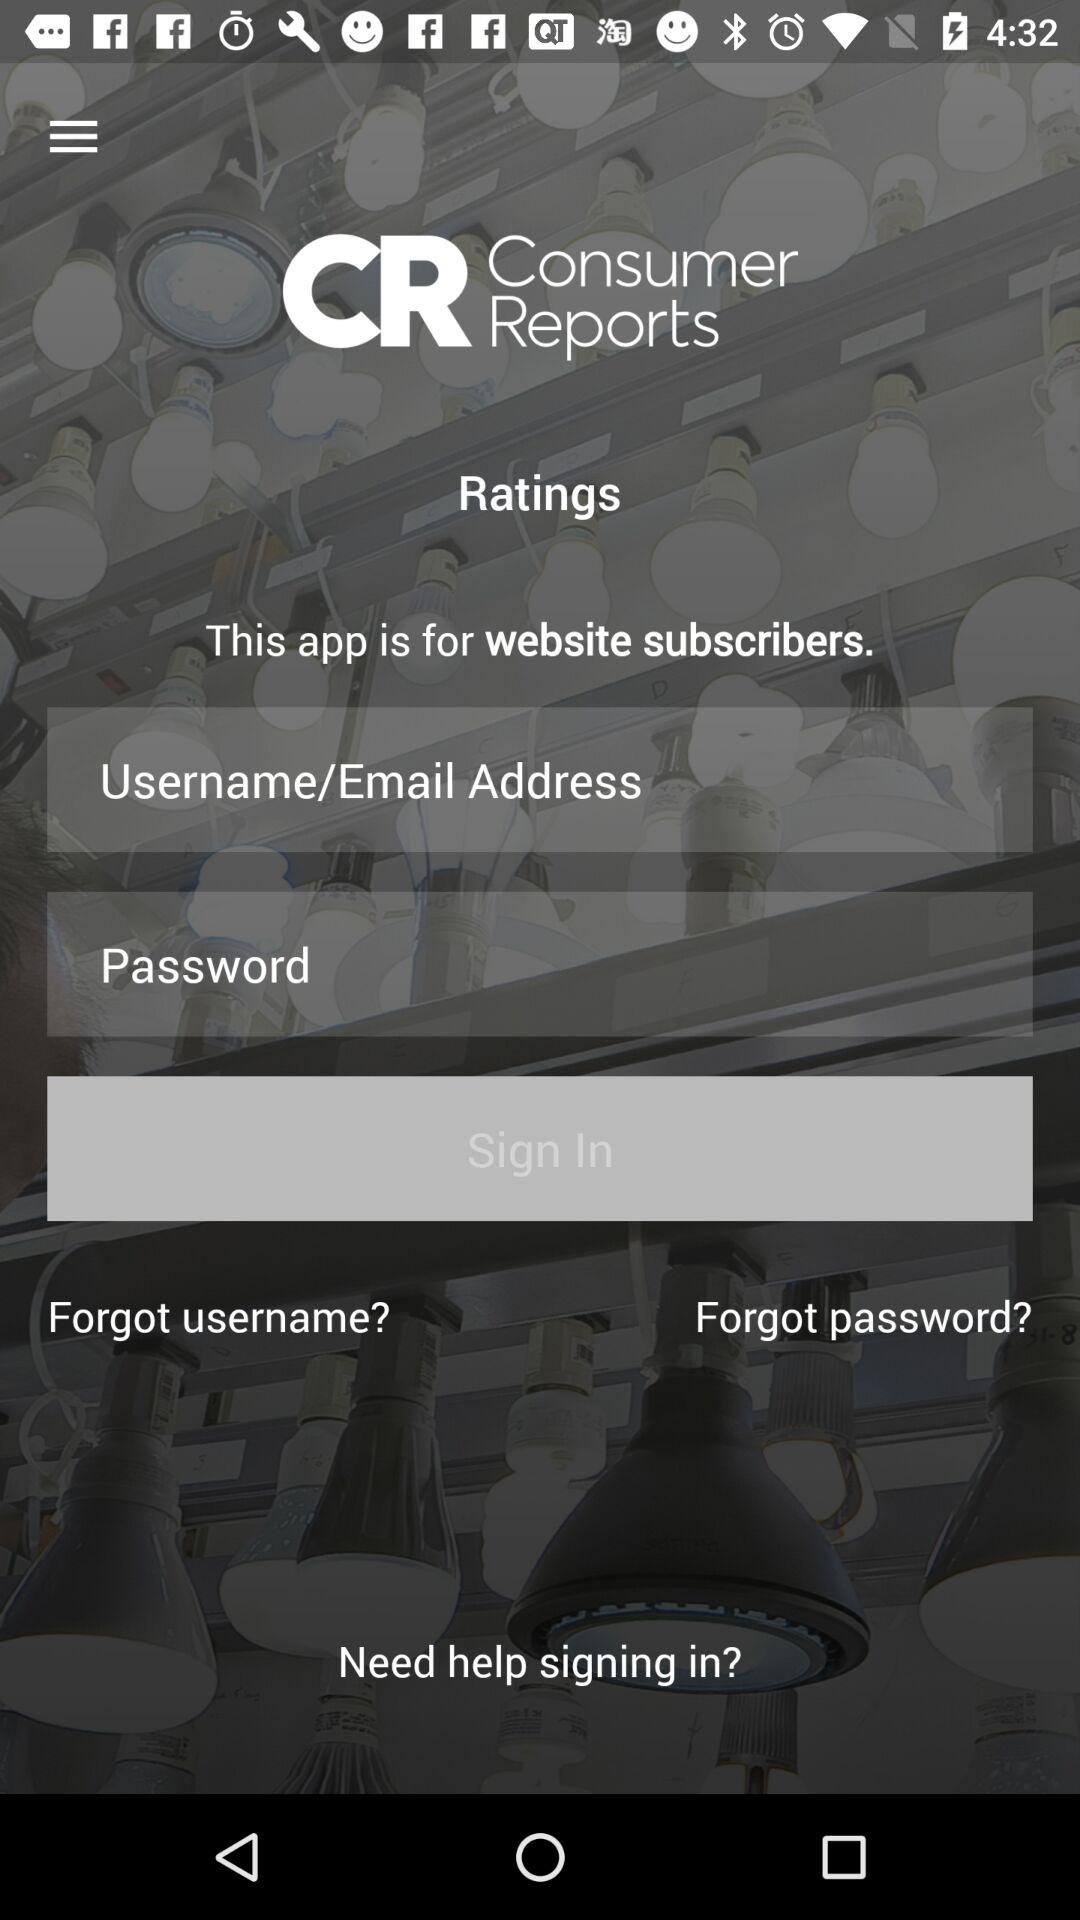Is the sign in form intended for new or existing users? The sign-in form is designed for existing users as it requests a username/email address and password. New users would typically need to find a 'Sign Up' or 'Register' option instead. 